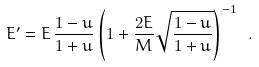<formula> <loc_0><loc_0><loc_500><loc_500>E ^ { \prime } = E \, \frac { 1 - u } { 1 + u } \left ( 1 + \frac { 2 E } { M } \sqrt { \frac { 1 - u } { 1 + u } } \right ) ^ { - 1 } \ .</formula> 